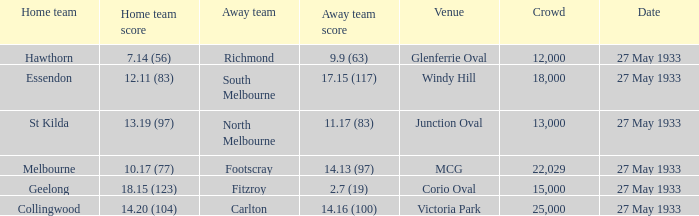20 (104), how many people were in the crowd? 25000.0. 